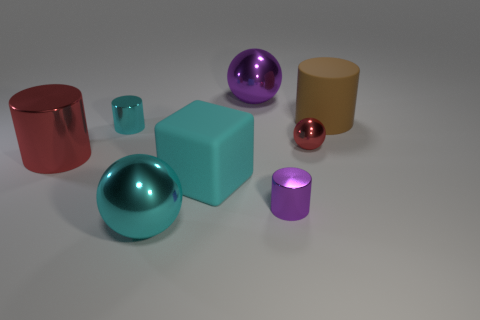Subtract all red balls. How many balls are left? 2 Subtract all red spheres. How many spheres are left? 2 Subtract all blocks. How many objects are left? 7 Subtract all purple cylinders. Subtract all tiny red shiny spheres. How many objects are left? 6 Add 8 small red objects. How many small red objects are left? 9 Add 6 matte blocks. How many matte blocks exist? 7 Add 1 big red shiny cylinders. How many objects exist? 9 Subtract 0 brown spheres. How many objects are left? 8 Subtract 1 cubes. How many cubes are left? 0 Subtract all yellow cylinders. Subtract all brown balls. How many cylinders are left? 4 